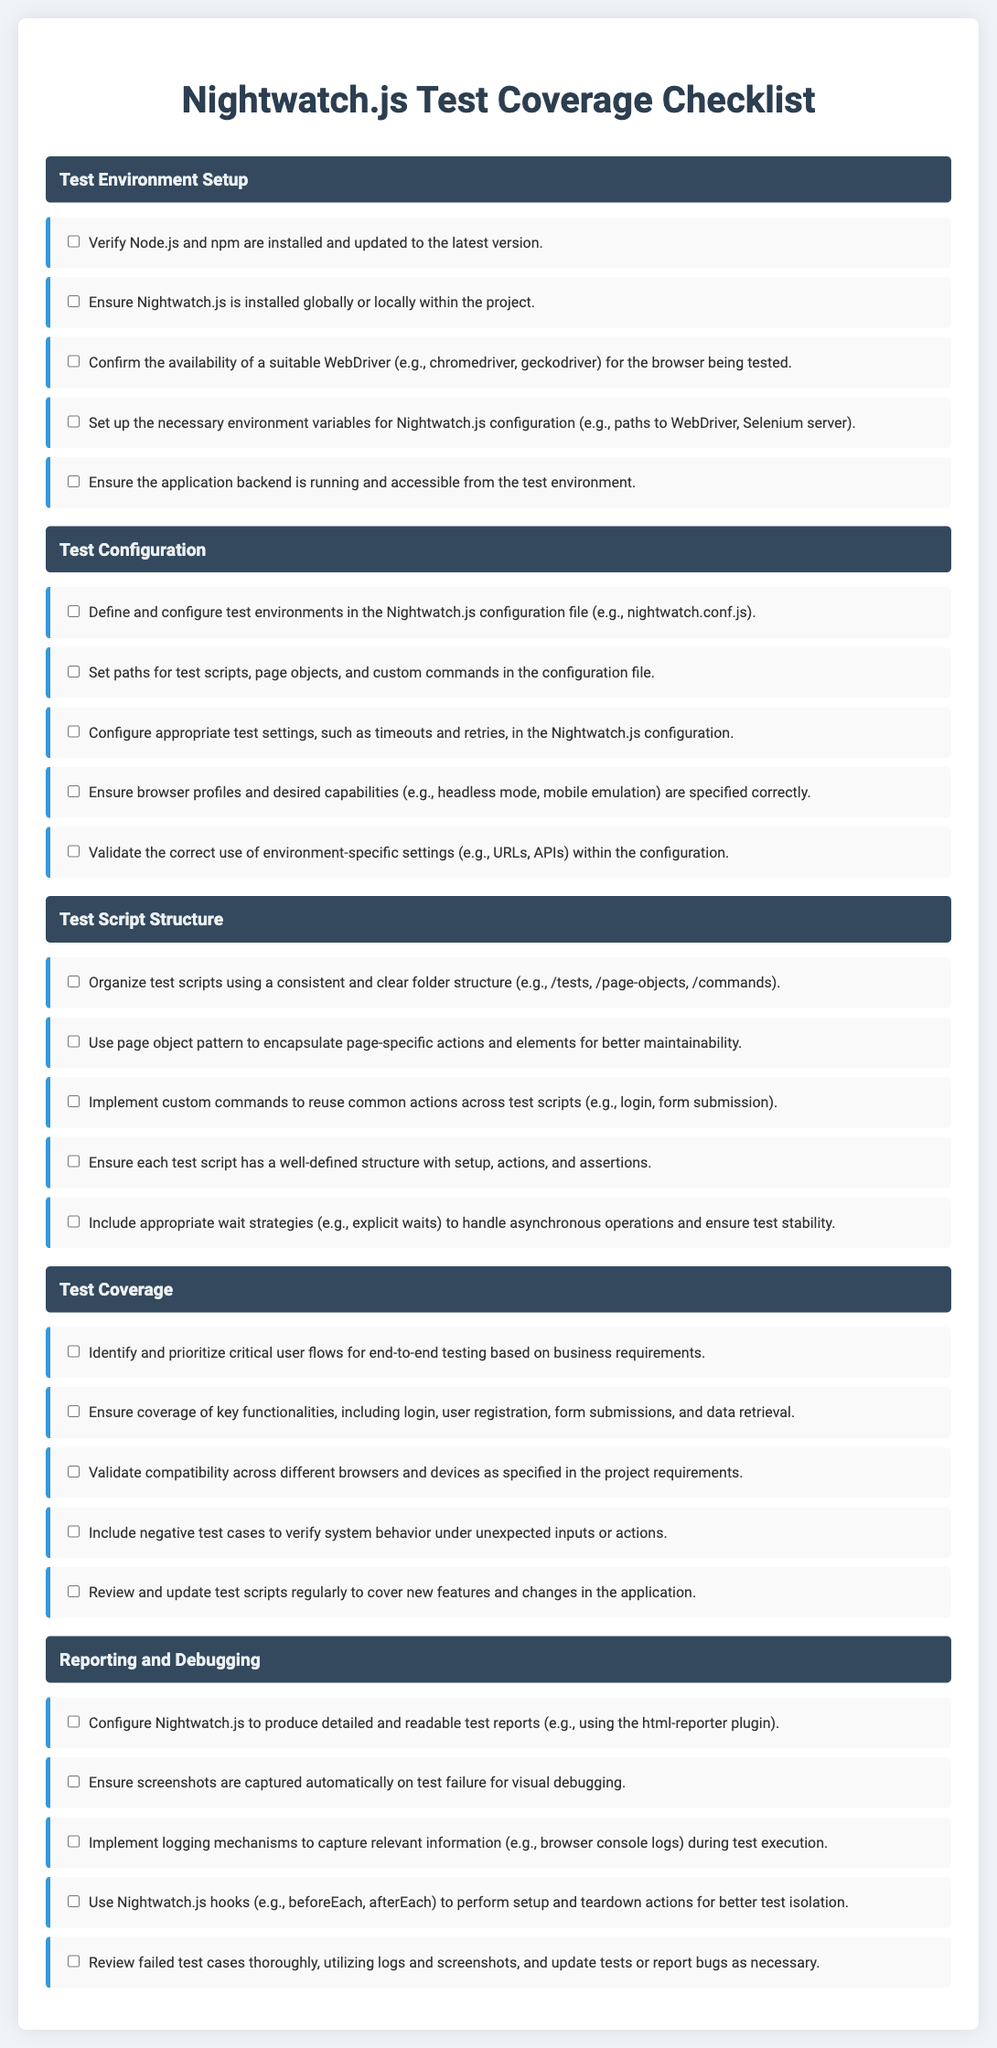What is the first category in the checklist? The first category listed in the checklist is "Test Environment Setup."
Answer: Test Environment Setup How many items are in the "Test Configuration" category? The "Test Configuration" category contains five items.
Answer: 5 What should be verified for the application backend in the test environment? The checklist states that the application backend should be running and accessible from the test environment.
Answer: Running and accessible What is the purpose of custom commands in test scripts? Custom commands are implemented to reuse common actions across test scripts, like login or form submission.
Answer: Reuse common actions What is one requirement for the reporting and debugging category? One requirement is to configure Nightwatch.js to produce detailed and readable test reports.
Answer: Detailed and readable test reports 